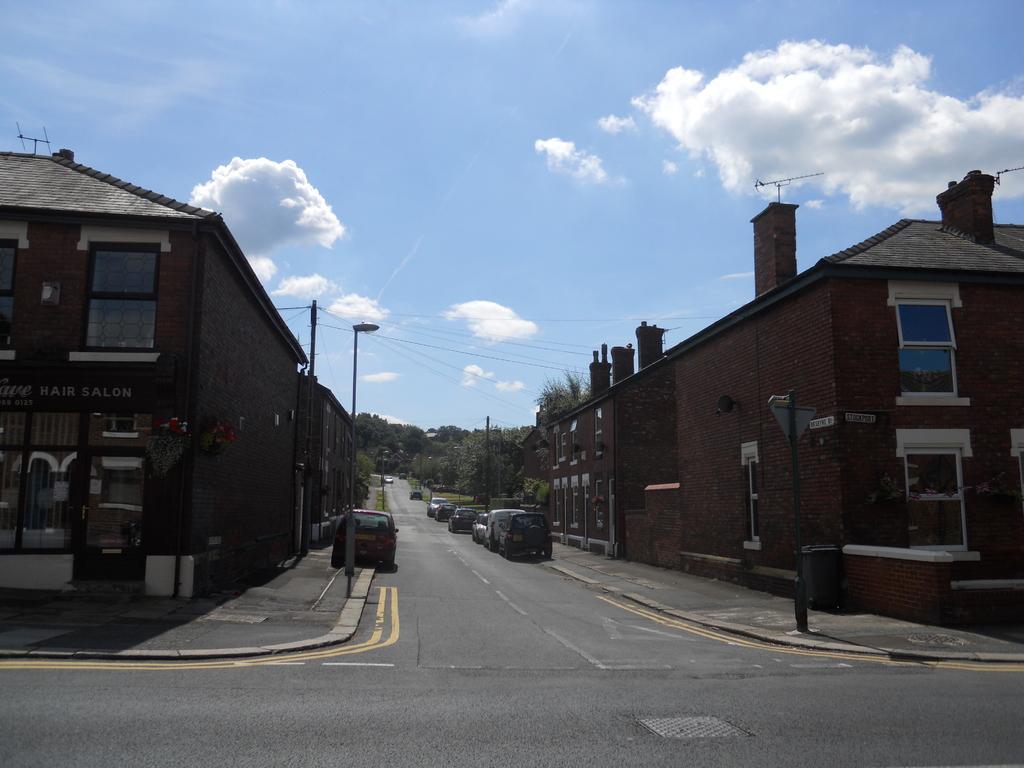How would you summarize this image in a sentence or two? In this picture there is a view of the road. In the front there are some cars parked on the roadside. On both the sides we can see brown color houses with roof tile and pipe chimneys. Behind we can see the street pole with cables and trees. 